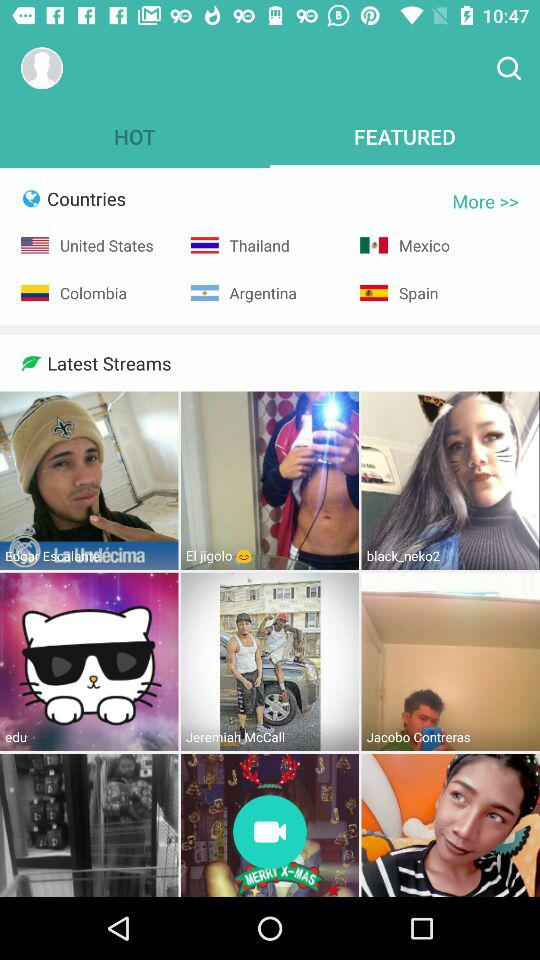What are the country options available? The country options available are "United States", "Thailand", "Mexico", "Colombia", "Argentina" and "Spain". 